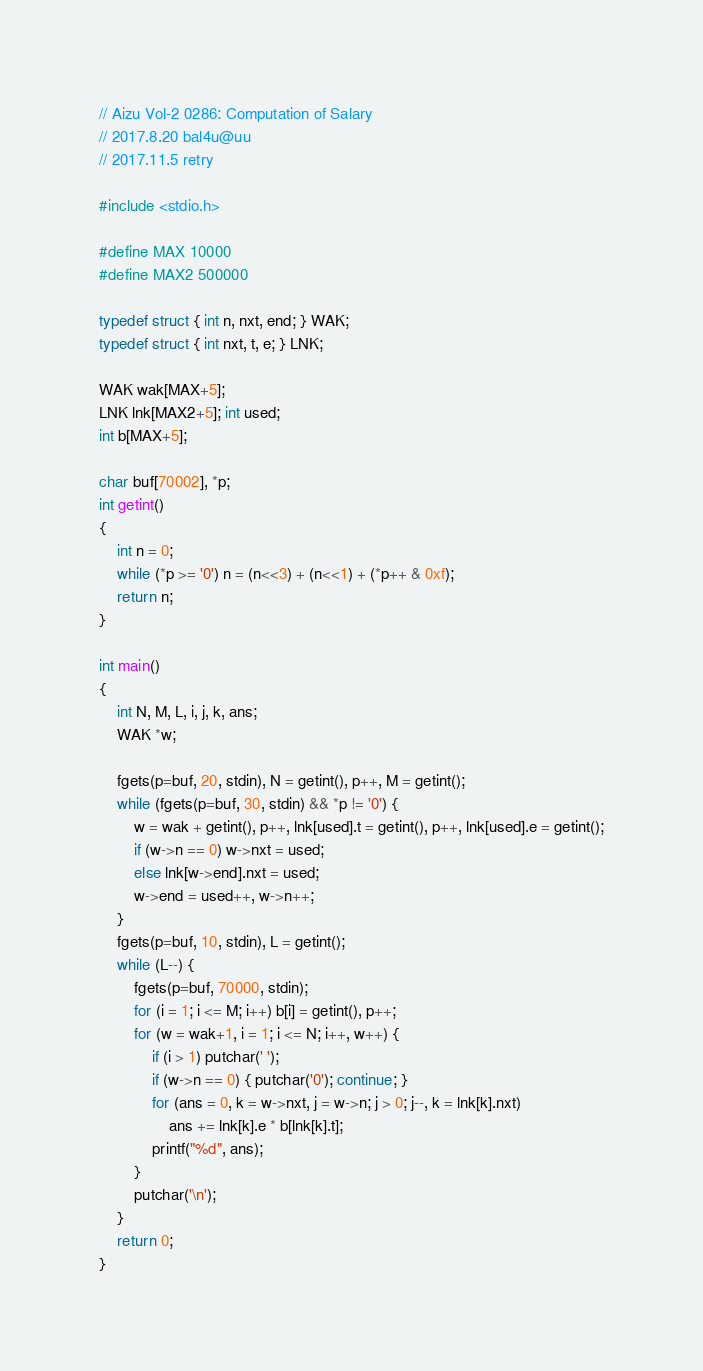Convert code to text. <code><loc_0><loc_0><loc_500><loc_500><_C_>// Aizu Vol-2 0286: Computation of Salary
// 2017.8.20 bal4u@uu
// 2017.11.5 retry

#include <stdio.h>

#define MAX 10000
#define MAX2 500000

typedef struct { int n, nxt, end; } WAK;
typedef struct { int nxt, t, e; } LNK;

WAK wak[MAX+5];
LNK lnk[MAX2+5]; int used;
int b[MAX+5];

char buf[70002], *p;
int getint()
{
	int n = 0;
	while (*p >= '0') n = (n<<3) + (n<<1) + (*p++ & 0xf);
	return n;
}

int main()
{
	int N, M, L, i, j, k, ans;
	WAK *w;

	fgets(p=buf, 20, stdin), N = getint(), p++, M = getint();
	while (fgets(p=buf, 30, stdin) && *p != '0') {
		w = wak + getint(), p++, lnk[used].t = getint(), p++, lnk[used].e = getint();
		if (w->n == 0) w->nxt = used;
		else lnk[w->end].nxt = used;
		w->end = used++, w->n++;
	}
	fgets(p=buf, 10, stdin), L = getint();
	while (L--) {
		fgets(p=buf, 70000, stdin);
		for (i = 1; i <= M; i++) b[i] = getint(), p++;
		for (w = wak+1, i = 1; i <= N; i++, w++) {
			if (i > 1) putchar(' ');
			if (w->n == 0) { putchar('0'); continue; }
			for (ans = 0, k = w->nxt, j = w->n; j > 0; j--, k = lnk[k].nxt)
				ans += lnk[k].e * b[lnk[k].t];
			printf("%d", ans);
		}
		putchar('\n');
	}
	return 0;
}</code> 